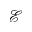Convert formula to latex. <formula><loc_0><loc_0><loc_500><loc_500>\mathcal { E }</formula> 